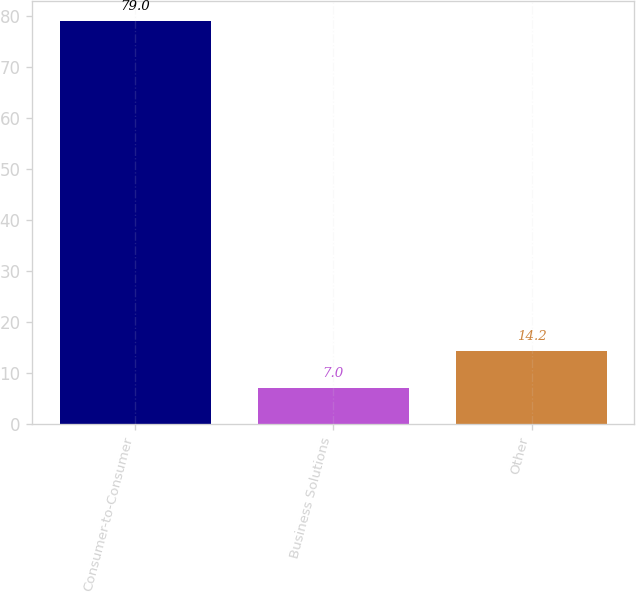Convert chart to OTSL. <chart><loc_0><loc_0><loc_500><loc_500><bar_chart><fcel>Consumer-to-Consumer<fcel>Business Solutions<fcel>Other<nl><fcel>79<fcel>7<fcel>14.2<nl></chart> 